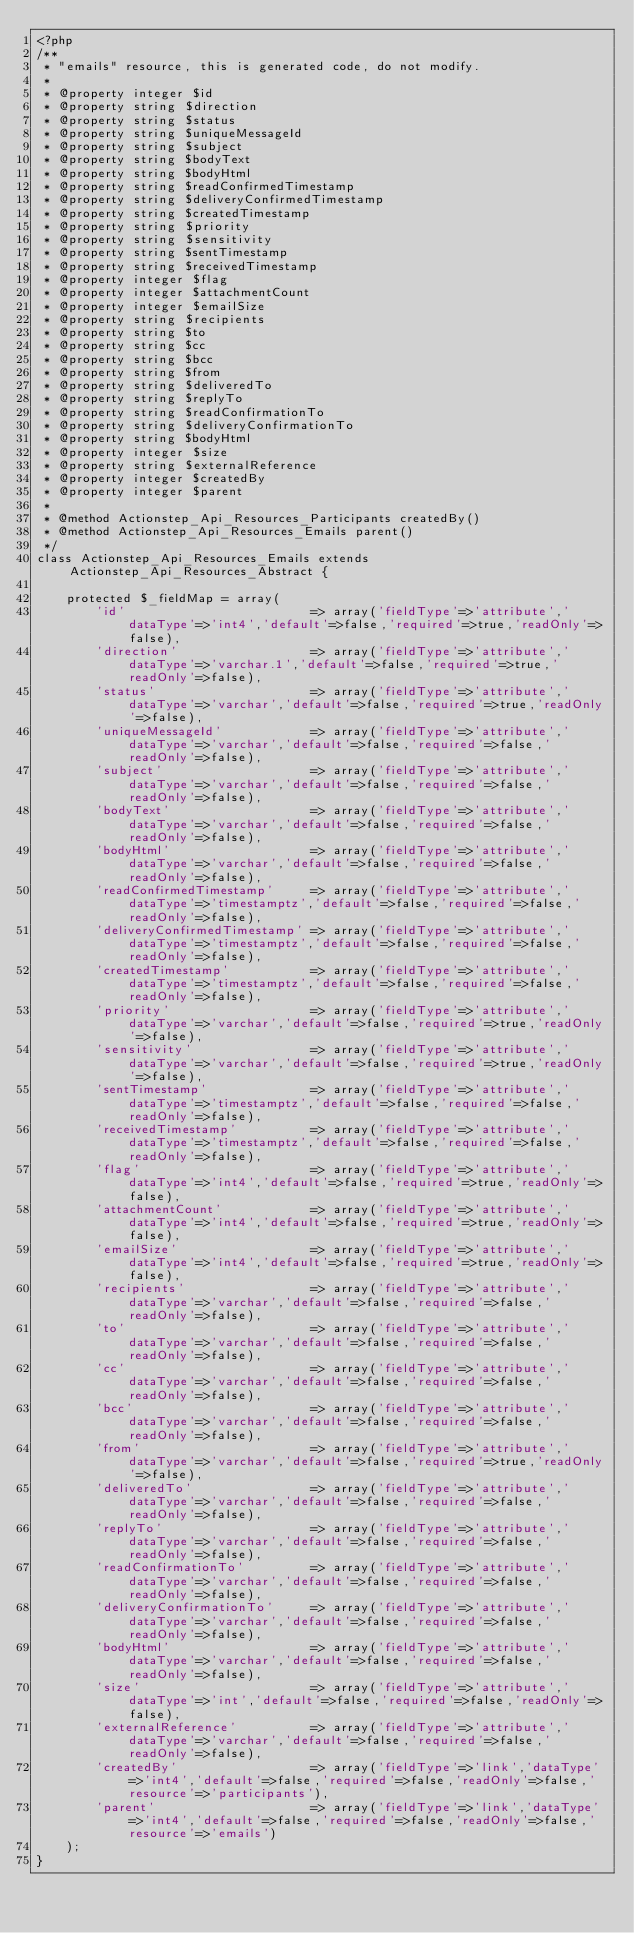Convert code to text. <code><loc_0><loc_0><loc_500><loc_500><_PHP_><?php
/**
 * "emails" resource, this is generated code, do not modify.
 *
 * @property integer $id
 * @property string $direction
 * @property string $status
 * @property string $uniqueMessageId
 * @property string $subject
 * @property string $bodyText
 * @property string $bodyHtml
 * @property string $readConfirmedTimestamp
 * @property string $deliveryConfirmedTimestamp
 * @property string $createdTimestamp
 * @property string $priority
 * @property string $sensitivity
 * @property string $sentTimestamp
 * @property string $receivedTimestamp
 * @property integer $flag
 * @property integer $attachmentCount
 * @property integer $emailSize
 * @property string $recipients
 * @property string $to
 * @property string $cc
 * @property string $bcc
 * @property string $from
 * @property string $deliveredTo
 * @property string $replyTo
 * @property string $readConfirmationTo
 * @property string $deliveryConfirmationTo
 * @property string $bodyHtml
 * @property integer $size
 * @property string $externalReference
 * @property integer $createdBy
 * @property integer $parent
 *
 * @method Actionstep_Api_Resources_Participants createdBy()
 * @method Actionstep_Api_Resources_Emails parent()
 */
class Actionstep_Api_Resources_Emails extends Actionstep_Api_Resources_Abstract {

    protected $_fieldMap = array(
        'id'                         => array('fieldType'=>'attribute','dataType'=>'int4','default'=>false,'required'=>true,'readOnly'=>false),
        'direction'                  => array('fieldType'=>'attribute','dataType'=>'varchar.1','default'=>false,'required'=>true,'readOnly'=>false),
        'status'                     => array('fieldType'=>'attribute','dataType'=>'varchar','default'=>false,'required'=>true,'readOnly'=>false),
        'uniqueMessageId'            => array('fieldType'=>'attribute','dataType'=>'varchar','default'=>false,'required'=>false,'readOnly'=>false),
        'subject'                    => array('fieldType'=>'attribute','dataType'=>'varchar','default'=>false,'required'=>false,'readOnly'=>false),
        'bodyText'                   => array('fieldType'=>'attribute','dataType'=>'varchar','default'=>false,'required'=>false,'readOnly'=>false),
        'bodyHtml'                   => array('fieldType'=>'attribute','dataType'=>'varchar','default'=>false,'required'=>false,'readOnly'=>false),
        'readConfirmedTimestamp'     => array('fieldType'=>'attribute','dataType'=>'timestamptz','default'=>false,'required'=>false,'readOnly'=>false),
        'deliveryConfirmedTimestamp' => array('fieldType'=>'attribute','dataType'=>'timestamptz','default'=>false,'required'=>false,'readOnly'=>false),
        'createdTimestamp'           => array('fieldType'=>'attribute','dataType'=>'timestamptz','default'=>false,'required'=>false,'readOnly'=>false),
        'priority'                   => array('fieldType'=>'attribute','dataType'=>'varchar','default'=>false,'required'=>true,'readOnly'=>false),
        'sensitivity'                => array('fieldType'=>'attribute','dataType'=>'varchar','default'=>false,'required'=>true,'readOnly'=>false),
        'sentTimestamp'              => array('fieldType'=>'attribute','dataType'=>'timestamptz','default'=>false,'required'=>false,'readOnly'=>false),
        'receivedTimestamp'          => array('fieldType'=>'attribute','dataType'=>'timestamptz','default'=>false,'required'=>false,'readOnly'=>false),
        'flag'                       => array('fieldType'=>'attribute','dataType'=>'int4','default'=>false,'required'=>true,'readOnly'=>false),
        'attachmentCount'            => array('fieldType'=>'attribute','dataType'=>'int4','default'=>false,'required'=>true,'readOnly'=>false),
        'emailSize'                  => array('fieldType'=>'attribute','dataType'=>'int4','default'=>false,'required'=>true,'readOnly'=>false),
        'recipients'                 => array('fieldType'=>'attribute','dataType'=>'varchar','default'=>false,'required'=>false,'readOnly'=>false),
        'to'                         => array('fieldType'=>'attribute','dataType'=>'varchar','default'=>false,'required'=>false,'readOnly'=>false),
        'cc'                         => array('fieldType'=>'attribute','dataType'=>'varchar','default'=>false,'required'=>false,'readOnly'=>false),
        'bcc'                        => array('fieldType'=>'attribute','dataType'=>'varchar','default'=>false,'required'=>false,'readOnly'=>false),
        'from'                       => array('fieldType'=>'attribute','dataType'=>'varchar','default'=>false,'required'=>true,'readOnly'=>false),
        'deliveredTo'                => array('fieldType'=>'attribute','dataType'=>'varchar','default'=>false,'required'=>false,'readOnly'=>false),
        'replyTo'                    => array('fieldType'=>'attribute','dataType'=>'varchar','default'=>false,'required'=>false,'readOnly'=>false),
        'readConfirmationTo'         => array('fieldType'=>'attribute','dataType'=>'varchar','default'=>false,'required'=>false,'readOnly'=>false),
        'deliveryConfirmationTo'     => array('fieldType'=>'attribute','dataType'=>'varchar','default'=>false,'required'=>false,'readOnly'=>false),
        'bodyHtml'                   => array('fieldType'=>'attribute','dataType'=>'varchar','default'=>false,'required'=>false,'readOnly'=>false),
        'size'                       => array('fieldType'=>'attribute','dataType'=>'int','default'=>false,'required'=>false,'readOnly'=>false),
        'externalReference'          => array('fieldType'=>'attribute','dataType'=>'varchar','default'=>false,'required'=>false,'readOnly'=>false),
        'createdBy'                  => array('fieldType'=>'link','dataType'=>'int4','default'=>false,'required'=>false,'readOnly'=>false,'resource'=>'participants'),
        'parent'                     => array('fieldType'=>'link','dataType'=>'int4','default'=>false,'required'=>false,'readOnly'=>false,'resource'=>'emails')
    );
}</code> 